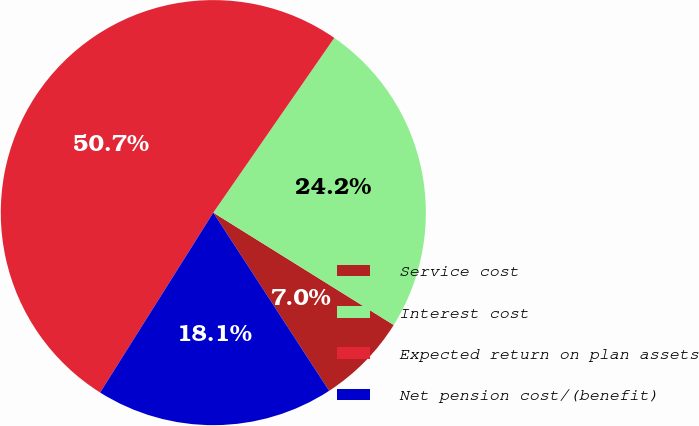Convert chart. <chart><loc_0><loc_0><loc_500><loc_500><pie_chart><fcel>Service cost<fcel>Interest cost<fcel>Expected return on plan assets<fcel>Net pension cost/(benefit)<nl><fcel>6.96%<fcel>24.23%<fcel>50.7%<fcel>18.11%<nl></chart> 